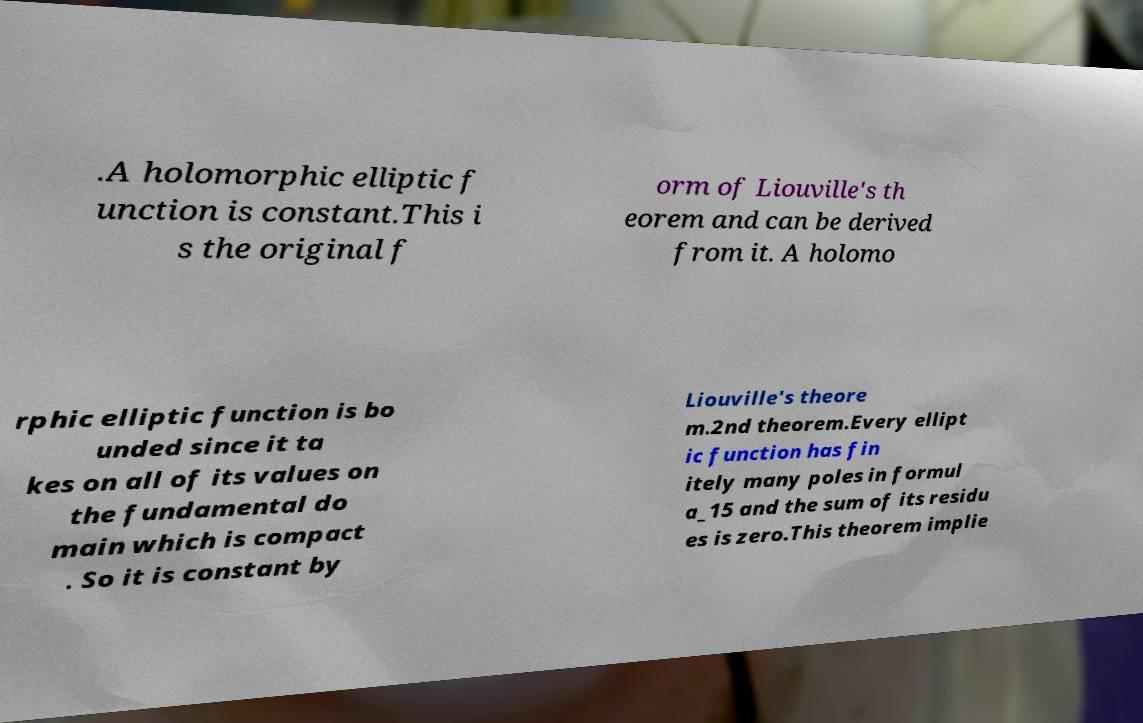What messages or text are displayed in this image? I need them in a readable, typed format. .A holomorphic elliptic f unction is constant.This i s the original f orm of Liouville's th eorem and can be derived from it. A holomo rphic elliptic function is bo unded since it ta kes on all of its values on the fundamental do main which is compact . So it is constant by Liouville's theore m.2nd theorem.Every ellipt ic function has fin itely many poles in formul a_15 and the sum of its residu es is zero.This theorem implie 